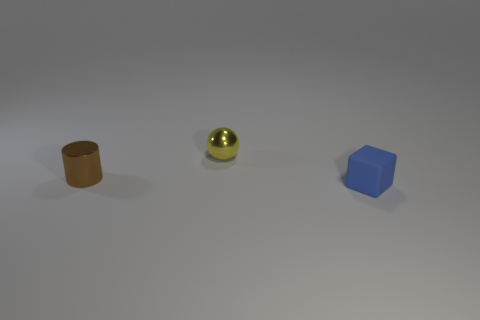How many other objects are the same shape as the small yellow object?
Give a very brief answer. 0. There is a small thing that is the same material as the yellow ball; what shape is it?
Offer a terse response. Cylinder. What is the color of the small object that is in front of the metallic sphere and left of the blue cube?
Offer a very short reply. Brown. Does the small object on the left side of the small yellow thing have the same material as the tiny cube?
Provide a succinct answer. No. Are there fewer rubber blocks that are left of the tiny rubber cube than brown things?
Keep it short and to the point. Yes. Are there any yellow things made of the same material as the small brown object?
Provide a short and direct response. Yes. Do the matte object and the shiny thing left of the small sphere have the same size?
Ensure brevity in your answer.  Yes. Do the tiny sphere and the block have the same material?
Offer a terse response. No. How many brown cylinders are right of the rubber block?
Provide a short and direct response. 0. What is the tiny thing that is on the right side of the brown object and in front of the tiny shiny ball made of?
Give a very brief answer. Rubber. 